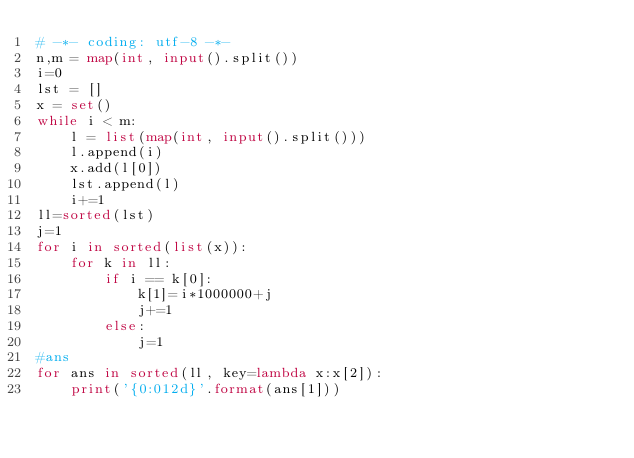Convert code to text. <code><loc_0><loc_0><loc_500><loc_500><_Python_># -*- coding: utf-8 -*-
n,m = map(int, input().split())
i=0
lst = []
x = set()
while i < m: 
    l = list(map(int, input().split()))
    l.append(i)
    x.add(l[0])
    lst.append(l)
    i+=1
ll=sorted(lst)
j=1
for i in sorted(list(x)):
    for k in ll:
        if i == k[0]:
            k[1]=i*1000000+j
            j+=1
        else:
            j=1
#ans
for ans in sorted(ll, key=lambda x:x[2]):
    print('{0:012d}'.format(ans[1]))

</code> 